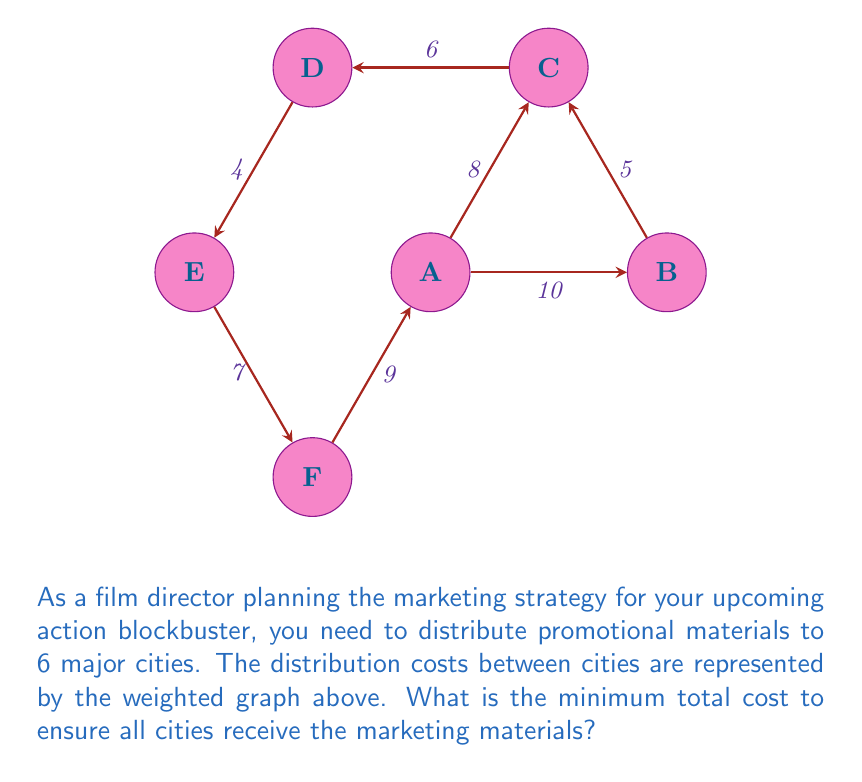Could you help me with this problem? To find the minimum total cost to distribute marketing materials to all cities, we need to find the minimum spanning tree (MST) of the given graph. We'll use Kruskal's algorithm to solve this problem:

1) Sort all edges by weight in ascending order:
   E-D (4), B-C (5), C-D (6), E-F (7), A-C (8), F-A (9), A-B (10)

2) Start with an empty set of edges and add edges one by one:
   - Add E-D (4)
   - Add B-C (5)
   - Add C-D (6)
   - Add E-F (7)
   - Add A-C (8)

3) Stop here as we have included 5 edges, which is enough to connect all 6 vertices (n-1 edges where n is the number of vertices).

4) The resulting MST includes the edges: E-D, B-C, C-D, E-F, and A-C.

5) Calculate the total cost by summing the weights of these edges:
   $$ \text{Total Cost} = 4 + 5 + 6 + 7 + 8 = 30 $$

Therefore, the minimum total cost to distribute marketing materials to all cities is 30 units.
Answer: 30 